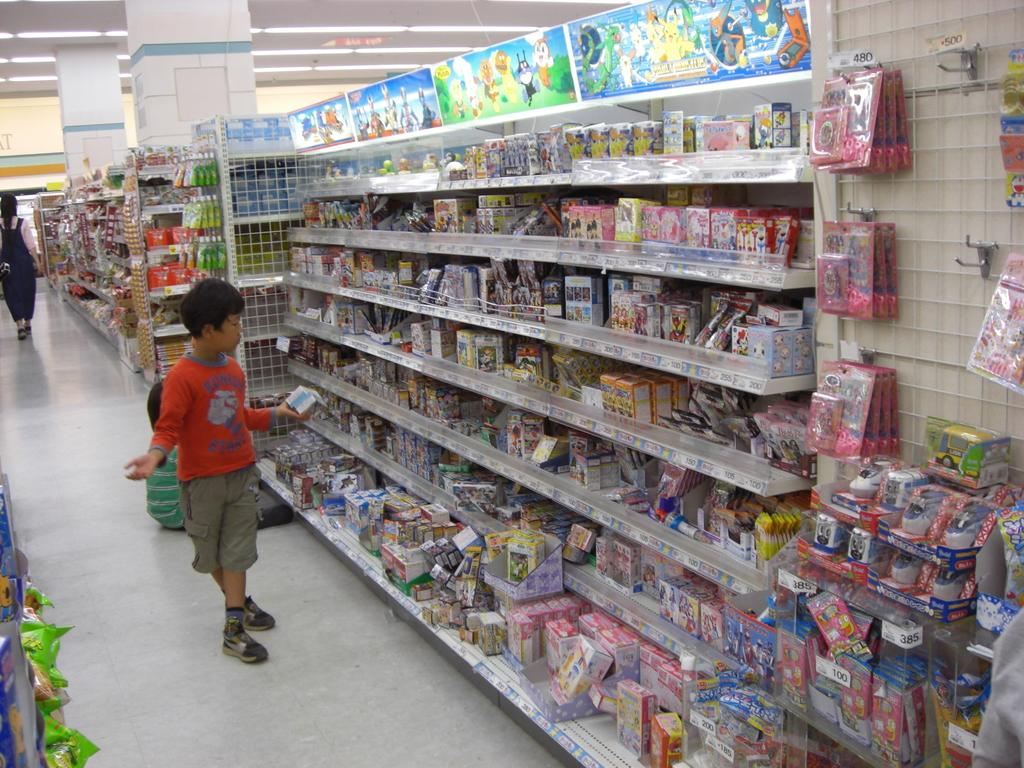What is the arrangement of the objects in the image? The objects are placed in racks. Are there any people visible in the image? Yes, there are two kids in front of the racks and a person in the left corner of the image. What type of stew is being prepared by the kids in the image? There is no stew being prepared in the image; the kids are simply standing in front of the racks. Is there an umbrella visible in the image? No, there is no umbrella present in the image. 